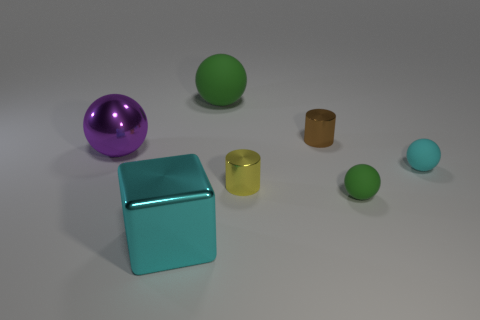Add 3 tiny cyan metallic cylinders. How many objects exist? 10 Subtract all brown cylinders. How many cylinders are left? 1 Subtract all large metal balls. How many balls are left? 3 Subtract 1 cubes. How many cubes are left? 0 Subtract all blocks. How many objects are left? 6 Subtract all blue cylinders. Subtract all red cubes. How many cylinders are left? 2 Subtract all blue cylinders. How many yellow cubes are left? 0 Subtract all brown shiny things. Subtract all green rubber balls. How many objects are left? 4 Add 4 brown shiny objects. How many brown shiny objects are left? 5 Add 7 tiny matte objects. How many tiny matte objects exist? 9 